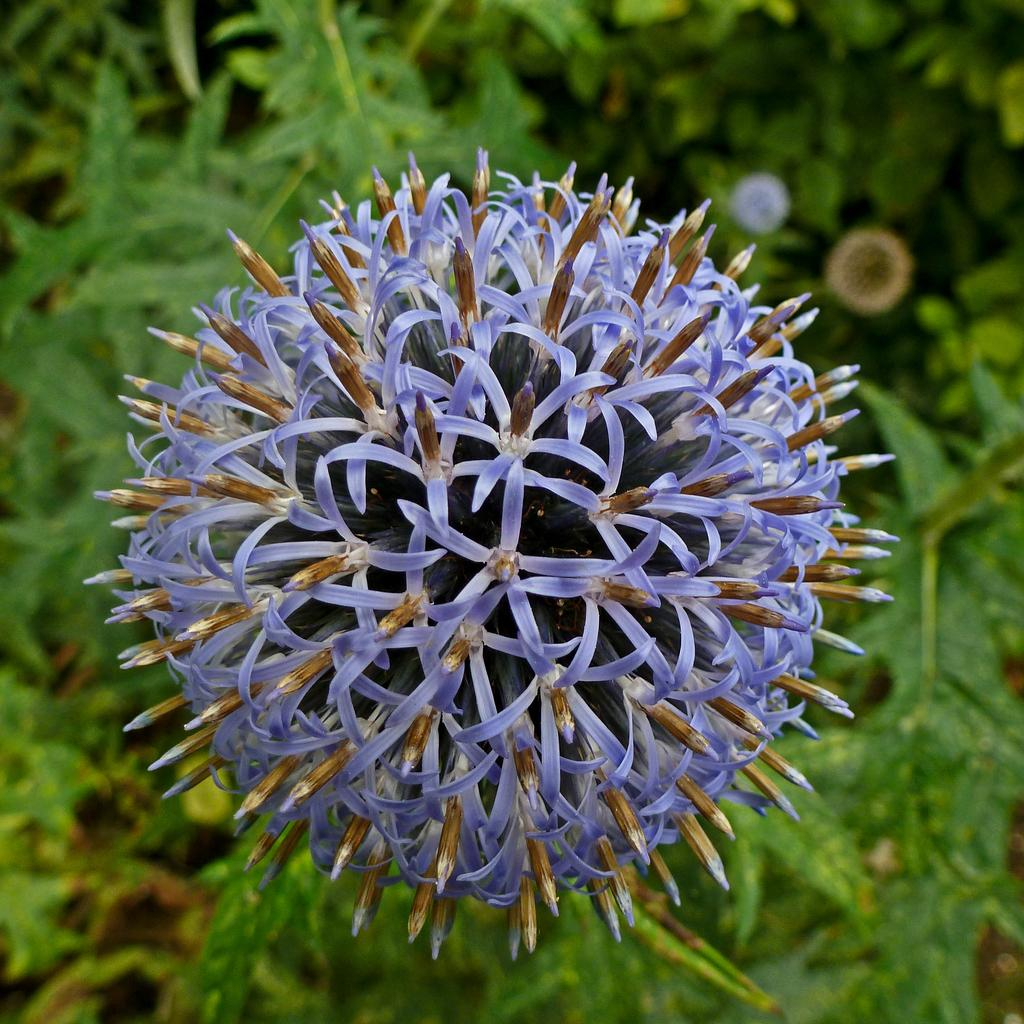What is the main subject of the image? There is a flower in the image. Can you describe the background of the image? There are leaves visible in the background of the image. What type of attraction can be seen in the image? There is no attraction present in the image; it features a flower and leaves in the background. What type of rice is being used to decorate the flower in the image? There is no rice present in the image; it features a flower and leaves in the background. 